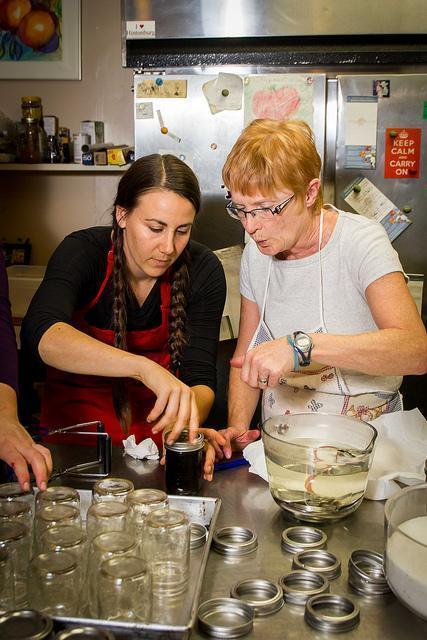How many women are wearing glasses?
Give a very brief answer. 1. How many bowls are there?
Give a very brief answer. 2. How many cups are in the picture?
Give a very brief answer. 3. How many bottles are there?
Give a very brief answer. 2. How many people can you see?
Give a very brief answer. 2. 